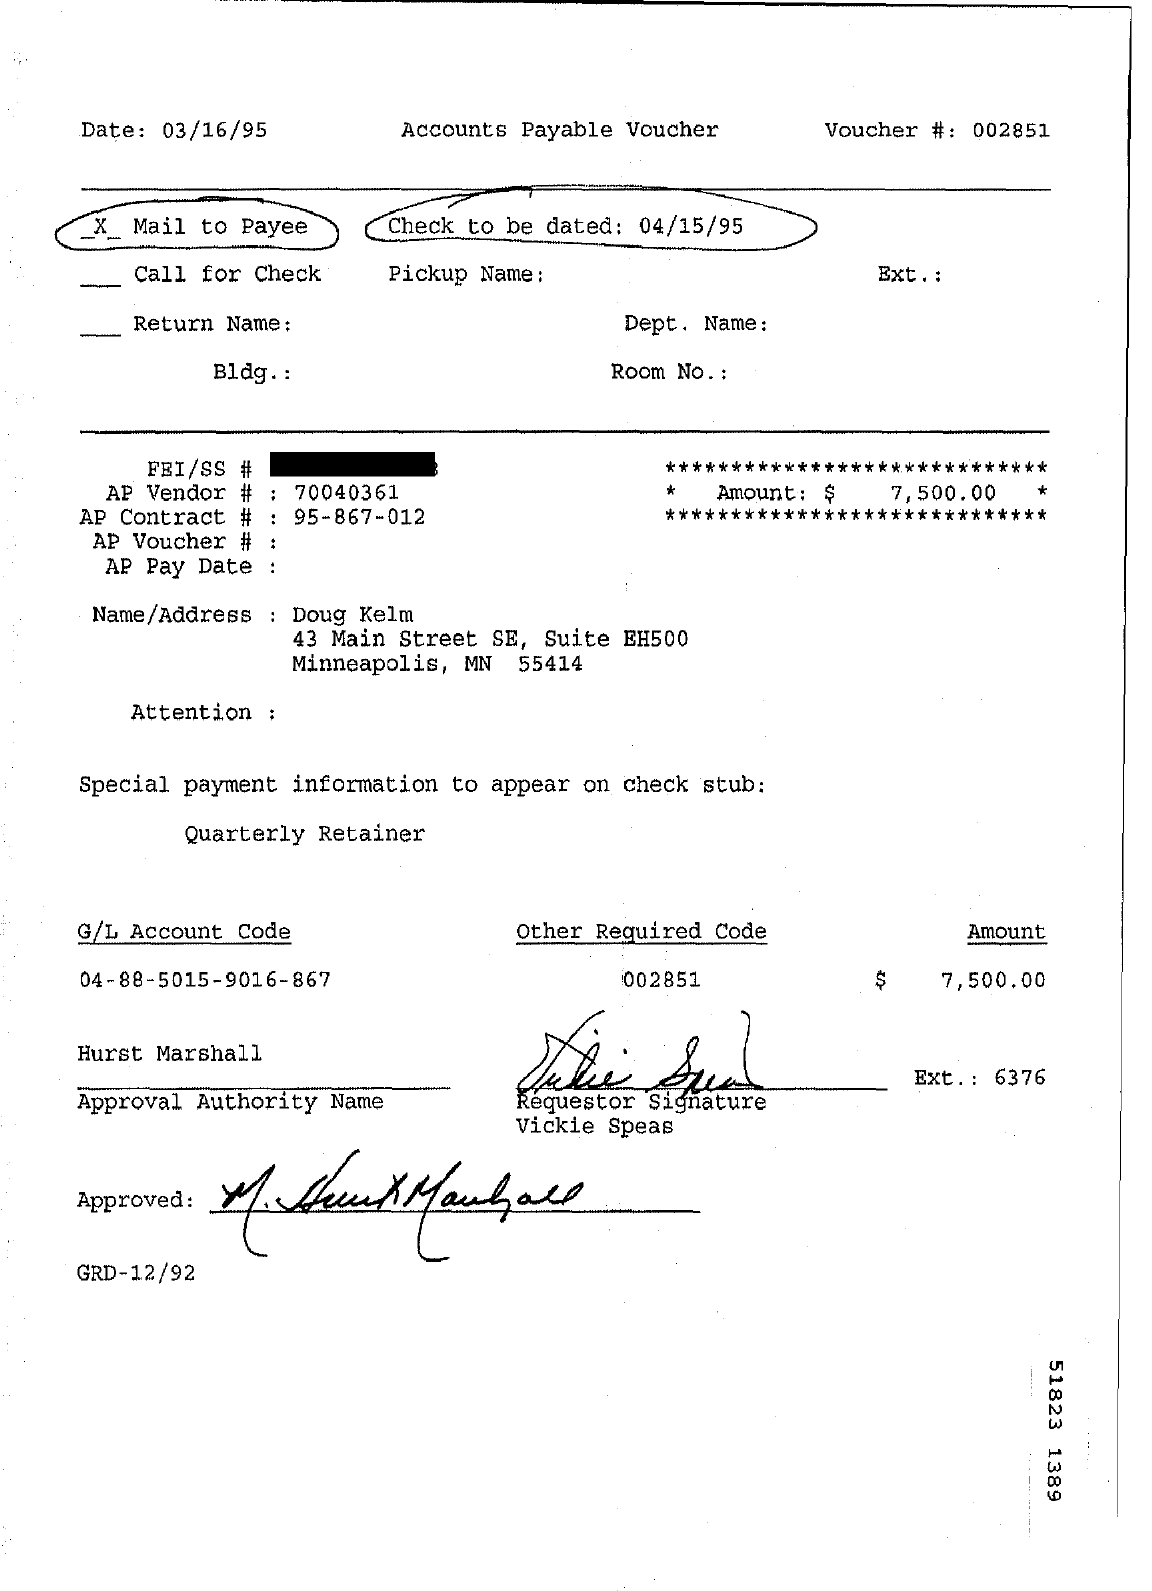What type of documentation is this?
Your response must be concise. Accounts payable voucher. When is the document dated?
Give a very brief answer. 03/16/95. What is the voucher number?
Make the answer very short. 002851. When is the check to be dated?
Make the answer very short. 04/15/95. What is the AP vendor number?
Your answer should be very brief. 70040361. What is the AP Contract #?
Offer a terse response. 95-867-012. What is the G/L Account Code mentioned?
Offer a terse response. 04-88-5015-9016-867. What is the other required code?
Your response must be concise. 002851. 